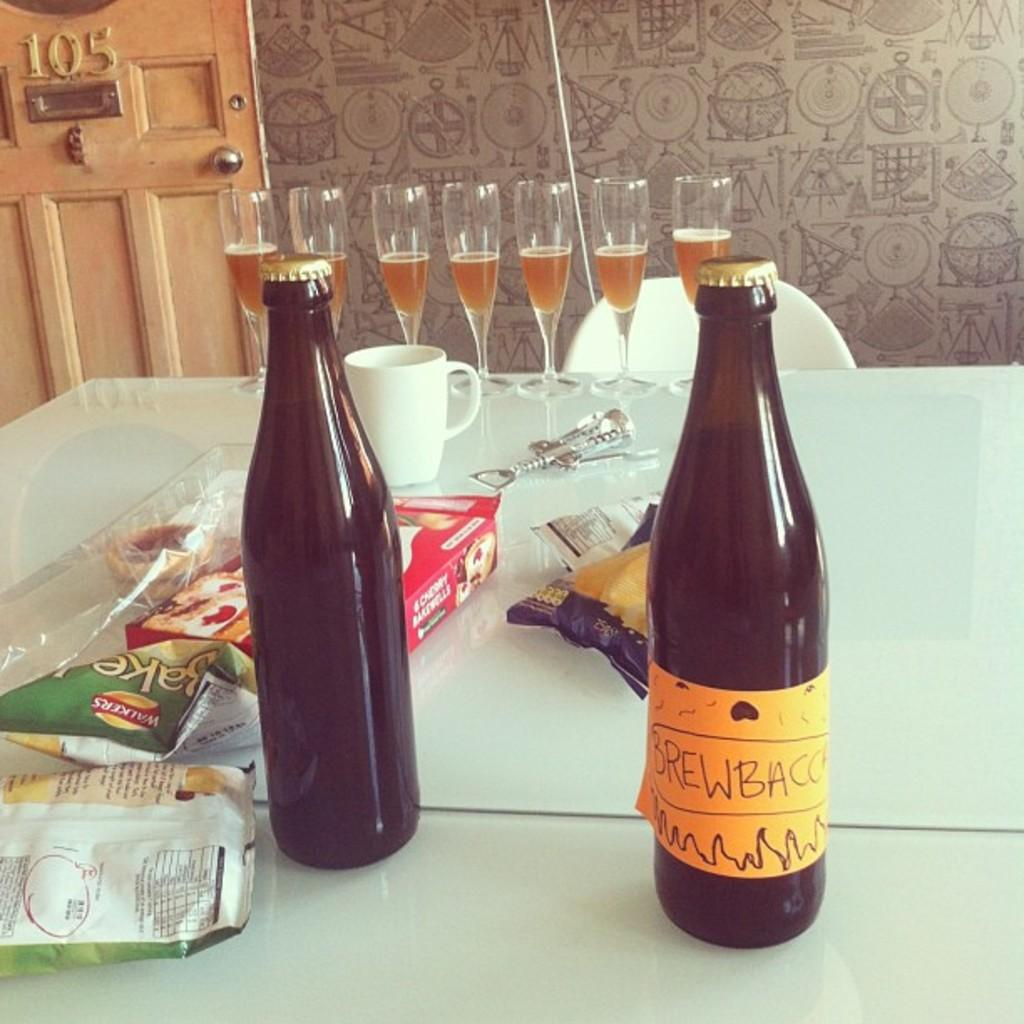<image>
Render a clear and concise summary of the photo. Food on a table with a bag of Walkers chips on top of it. 